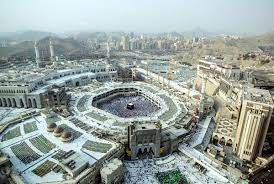How important is the Kaaba in Islamic traditions? The Kaaba is of paramount importance in Islamic tradition. It is considered the 'House of Allah' and represents the metaphorical center of the Muslim world. During Hajj, which is the largest annual Islamic pilgrimage, millions of Muslims travel to Mecca to perform Tawaf, which involves circling the Kaaba seven times in a counter-clockwise direction. This act signifies unity among believers, as all Muslims around the world face the Kaaba during their daily prayers, reinforcing a sense of global spiritual unison and devotion. 